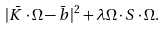Convert formula to latex. <formula><loc_0><loc_0><loc_500><loc_500>| \bar { K } \cdot \Omega - \bar { b } | ^ { 2 } + \lambda \Omega \cdot S \cdot \Omega .</formula> 